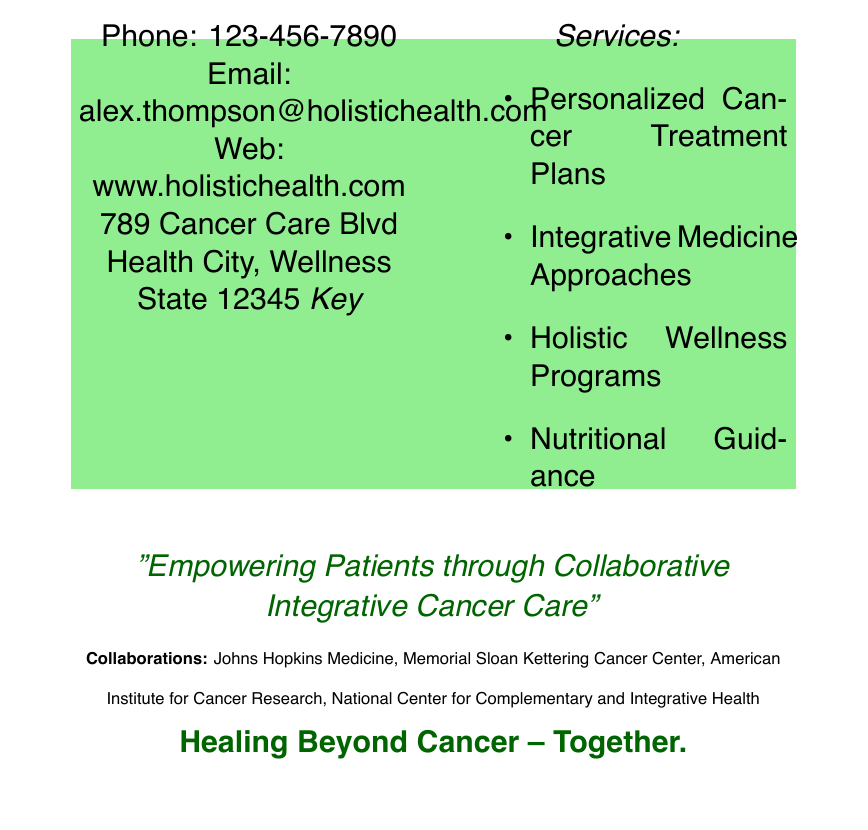what is the name of the oncologist? The name of the oncologist is prominently displayed at the top of the business card.
Answer: Dr. Alex Thompson, MD what is the specialty of Dr. Alex Thompson? The business card specifies the professional title directly under the name.
Answer: Oncologist & Integrative Medicine Specialist what is the location of the Holistic Health Cancer Care Center? The address of the center is provided in the document under contact information.
Answer: 789 Cancer Care Blvd, Health City, Wellness State 12345 what services are offered at the Holistic Health Cancer Care Center? The business card lists key services in a bulleted format.
Answer: Personalized Cancer Treatment Plans, Integrative Medicine Approaches, Holistic Wellness Programs, Nutritional Guidance which organizations does Dr. Alex Thompson collaborate with? Collaborations are mentioned towards the bottom of the card, listing several partner organizations.
Answer: Johns Hopkins Medicine, Memorial Sloan Kettering Cancer Center, American Institute for Cancer Research, National Center for Complementary and Integrative Health what is the contact phone number for Dr. Alex Thompson? The contact phone number is provided clearly in the document.
Answer: 123-456-7890 what is the mission statement on the business card? A quote is included on the card that summarizes the doctor's mission in patient care.
Answer: "Empowering Patients through Collaborative Integrative Cancer Care" 